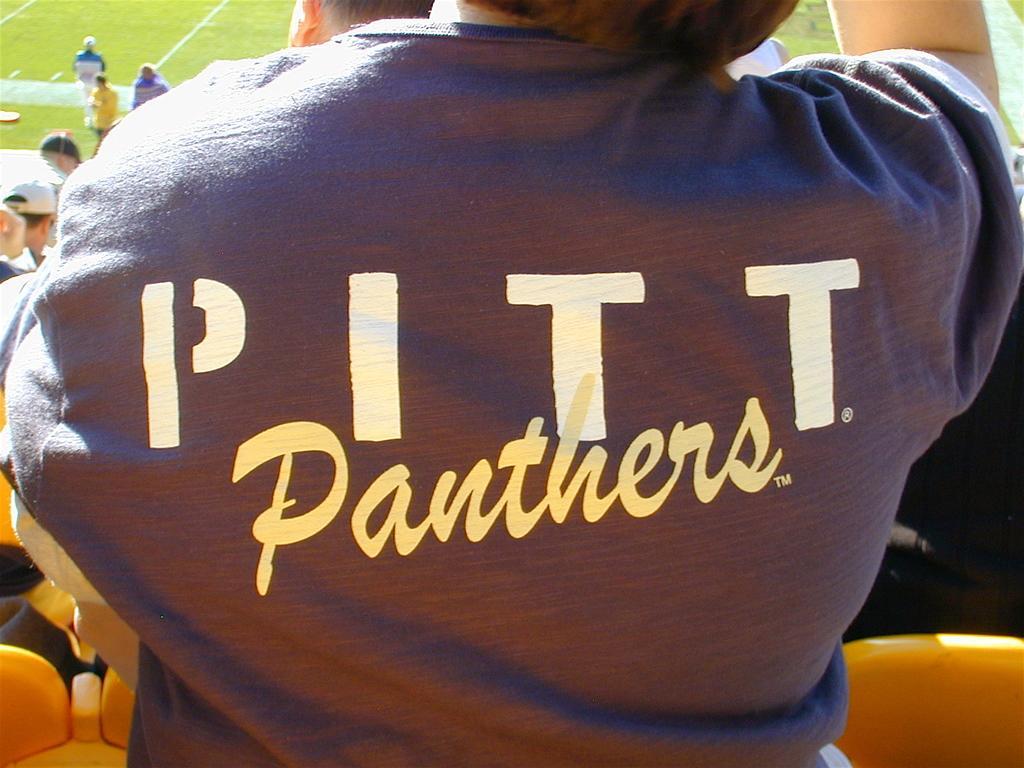In one or two sentences, can you explain what this image depicts? In the image few people are standing. In front of them there are some chairs. In top left corner of the image few people are standing. Behind them there is grass. 